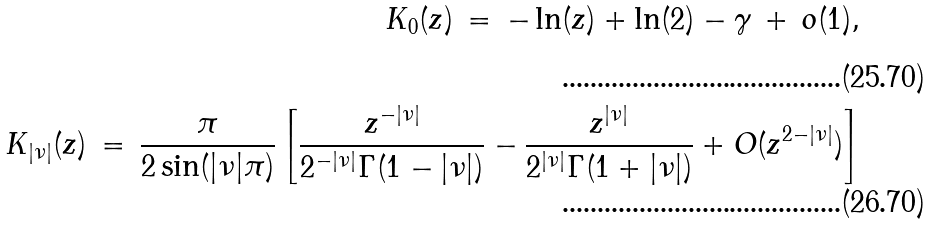<formula> <loc_0><loc_0><loc_500><loc_500>K _ { 0 } ( z ) \, = \, - \ln ( z ) + \ln ( 2 ) - \gamma \, + \, o ( 1 ) , \\ K _ { | \nu | } ( z ) \, = \, \frac { \pi } { 2 \sin ( | \nu | \pi ) } \left [ \frac { z ^ { - | \nu | } } { 2 ^ { - | \nu | } \Gamma ( 1 - | \nu | ) } - \frac { z ^ { | \nu | } } { 2 ^ { | \nu | } \Gamma ( 1 + | \nu | ) } + O ( z ^ { 2 - | \nu | } ) \right ]</formula> 